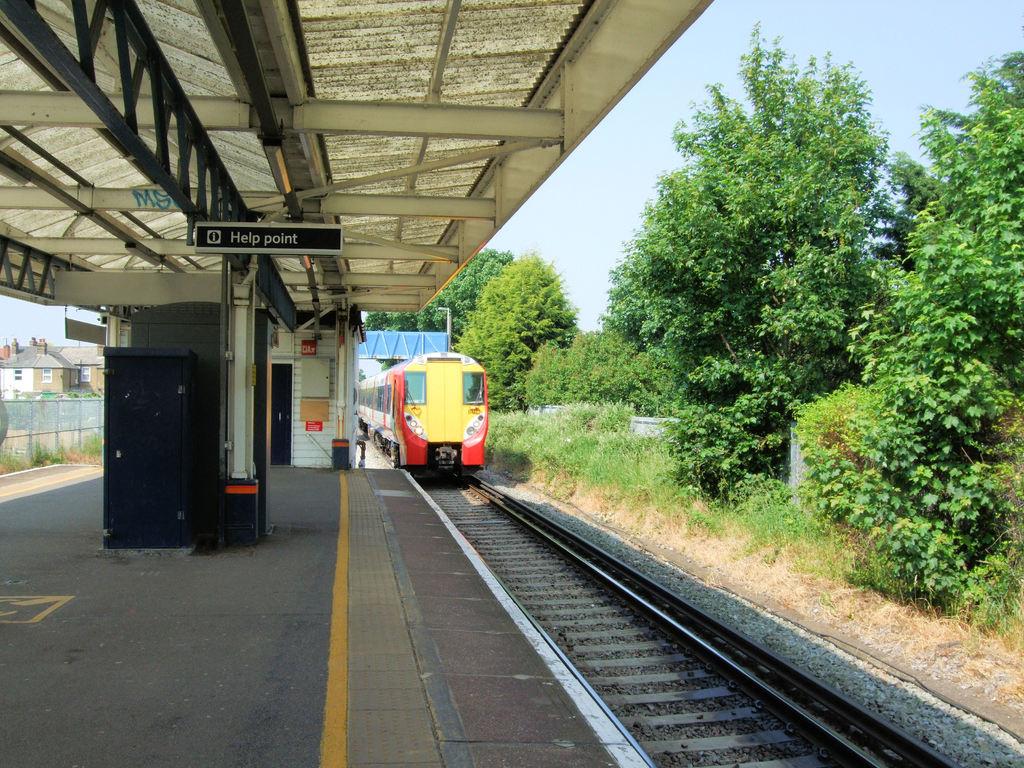What point is mentioned, with the sign?
Provide a short and direct response. Help. What is written on the top of the front of the train?
Provide a succinct answer. Unanswerable. 